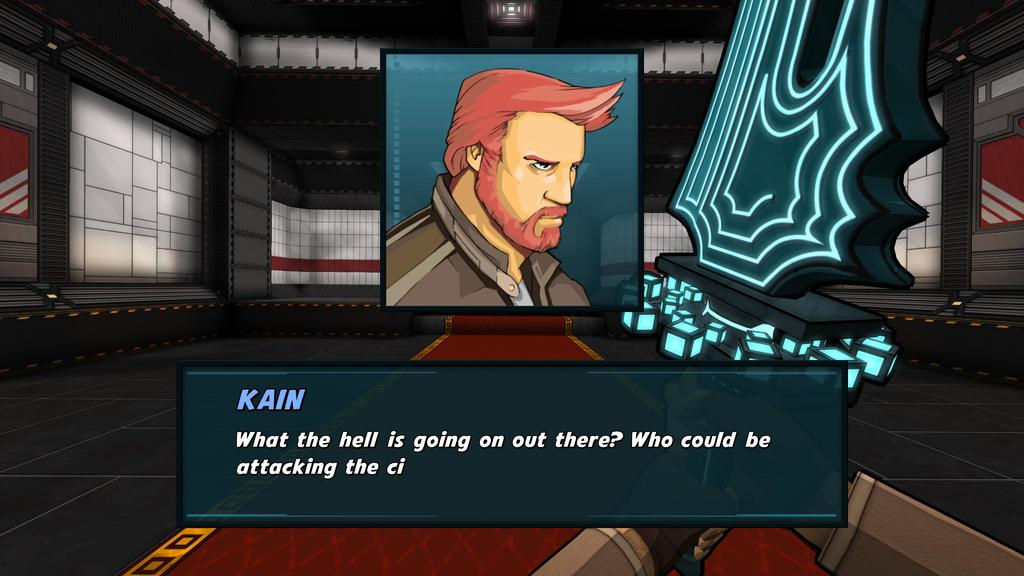What body part is visible in the image? There is a person's hand in the image. What facial feature is visible in the image? There is a person's face in the image. What type of structure is present in the image? There are walls in the image. What type of object is present in the image? There is an object in the image. What type of flooring is visible in the image? There is a carpet in the image. What type of badge is the person wearing in the image? There is no badge visible in the image. What type of ship is present in the image? There is no ship present in the image. 